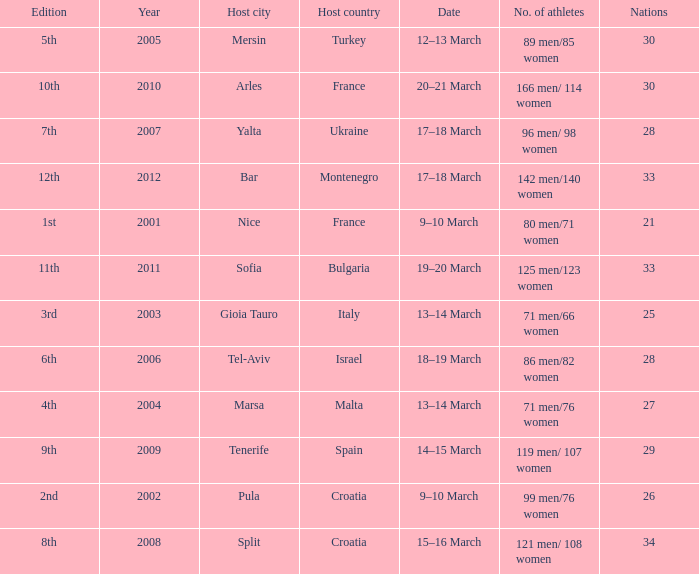What was the number of athletes in the host city of Nice? 80 men/71 women. 